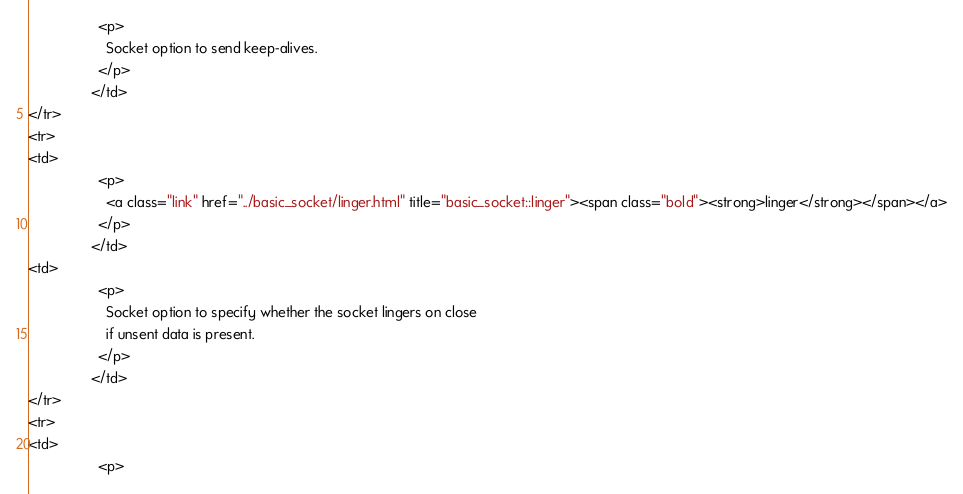Convert code to text. <code><loc_0><loc_0><loc_500><loc_500><_HTML_>                  <p>
                    Socket option to send keep-alives.
                  </p>
                </td>
</tr>
<tr>
<td>
                  <p>
                    <a class="link" href="../basic_socket/linger.html" title="basic_socket::linger"><span class="bold"><strong>linger</strong></span></a>
                  </p>
                </td>
<td>
                  <p>
                    Socket option to specify whether the socket lingers on close
                    if unsent data is present.
                  </p>
                </td>
</tr>
<tr>
<td>
                  <p></code> 